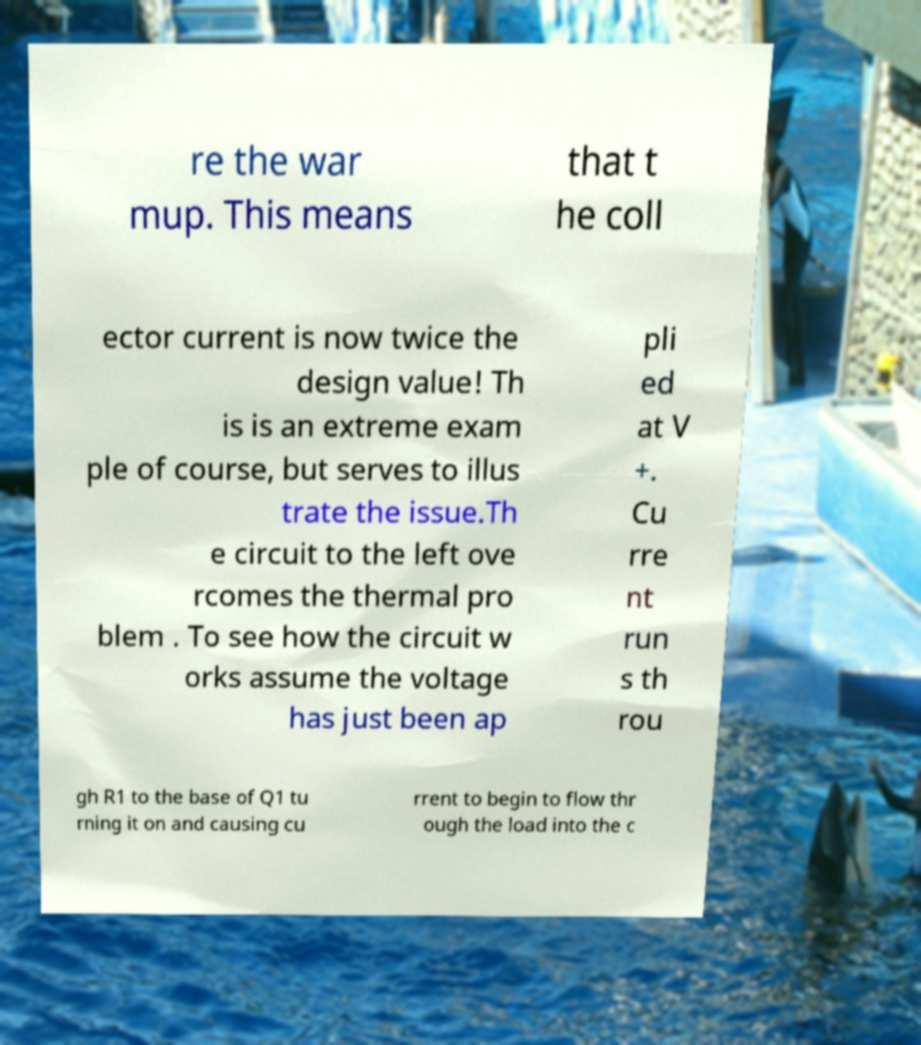Could you extract and type out the text from this image? re the war mup. This means that t he coll ector current is now twice the design value! Th is is an extreme exam ple of course, but serves to illus trate the issue.Th e circuit to the left ove rcomes the thermal pro blem . To see how the circuit w orks assume the voltage has just been ap pli ed at V +. Cu rre nt run s th rou gh R1 to the base of Q1 tu rning it on and causing cu rrent to begin to flow thr ough the load into the c 